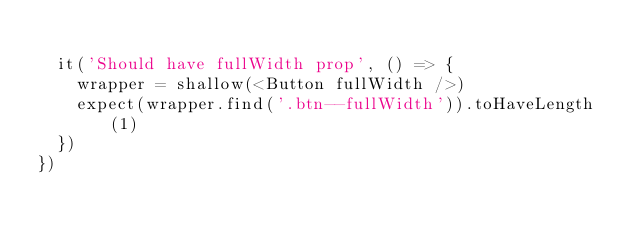Convert code to text. <code><loc_0><loc_0><loc_500><loc_500><_TypeScript_>
  it('Should have fullWidth prop', () => {
    wrapper = shallow(<Button fullWidth />)
    expect(wrapper.find('.btn--fullWidth')).toHaveLength(1)
  })
})
</code> 